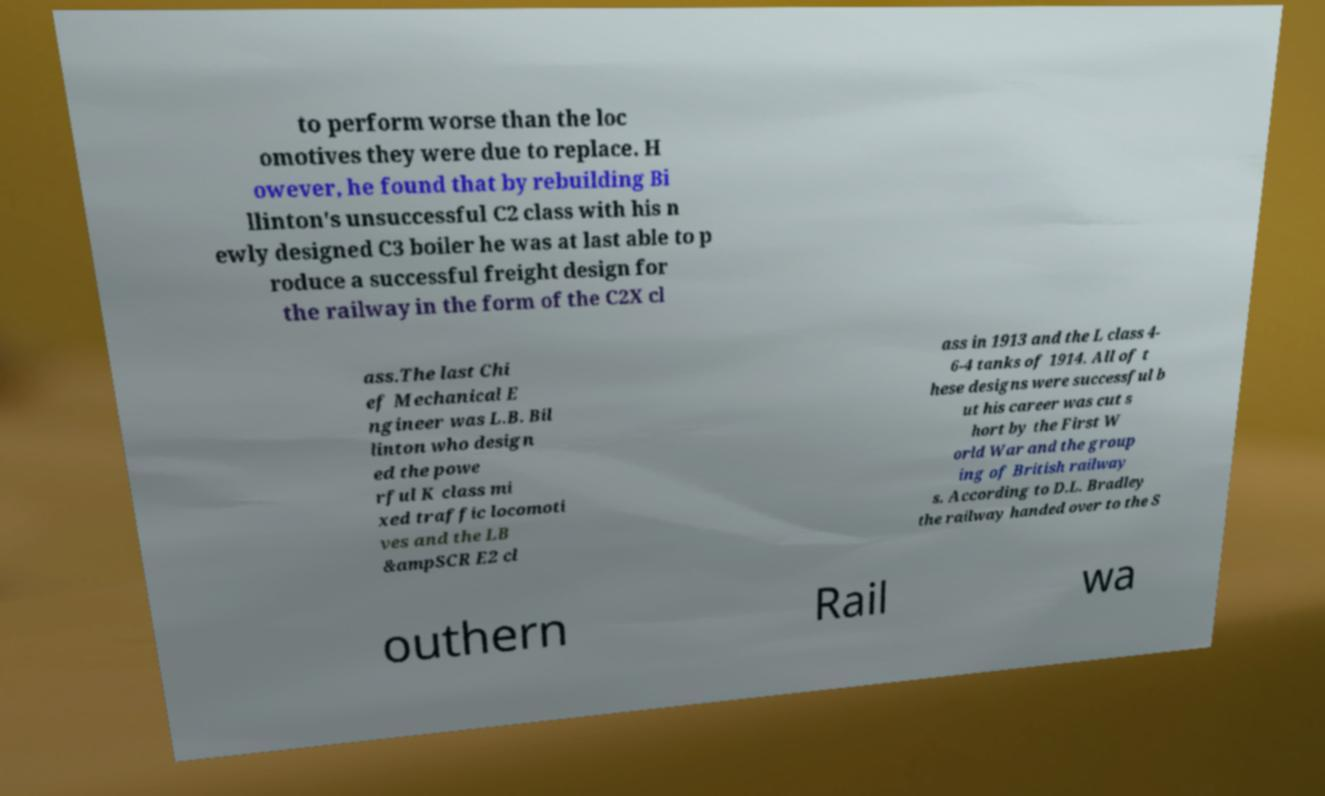Can you read and provide the text displayed in the image?This photo seems to have some interesting text. Can you extract and type it out for me? to perform worse than the loc omotives they were due to replace. H owever, he found that by rebuilding Bi llinton's unsuccessful C2 class with his n ewly designed C3 boiler he was at last able to p roduce a successful freight design for the railway in the form of the C2X cl ass.The last Chi ef Mechanical E ngineer was L.B. Bil linton who design ed the powe rful K class mi xed traffic locomoti ves and the LB &ampSCR E2 cl ass in 1913 and the L class 4- 6-4 tanks of 1914. All of t hese designs were successful b ut his career was cut s hort by the First W orld War and the group ing of British railway s. According to D.L. Bradley the railway handed over to the S outhern Rail wa 